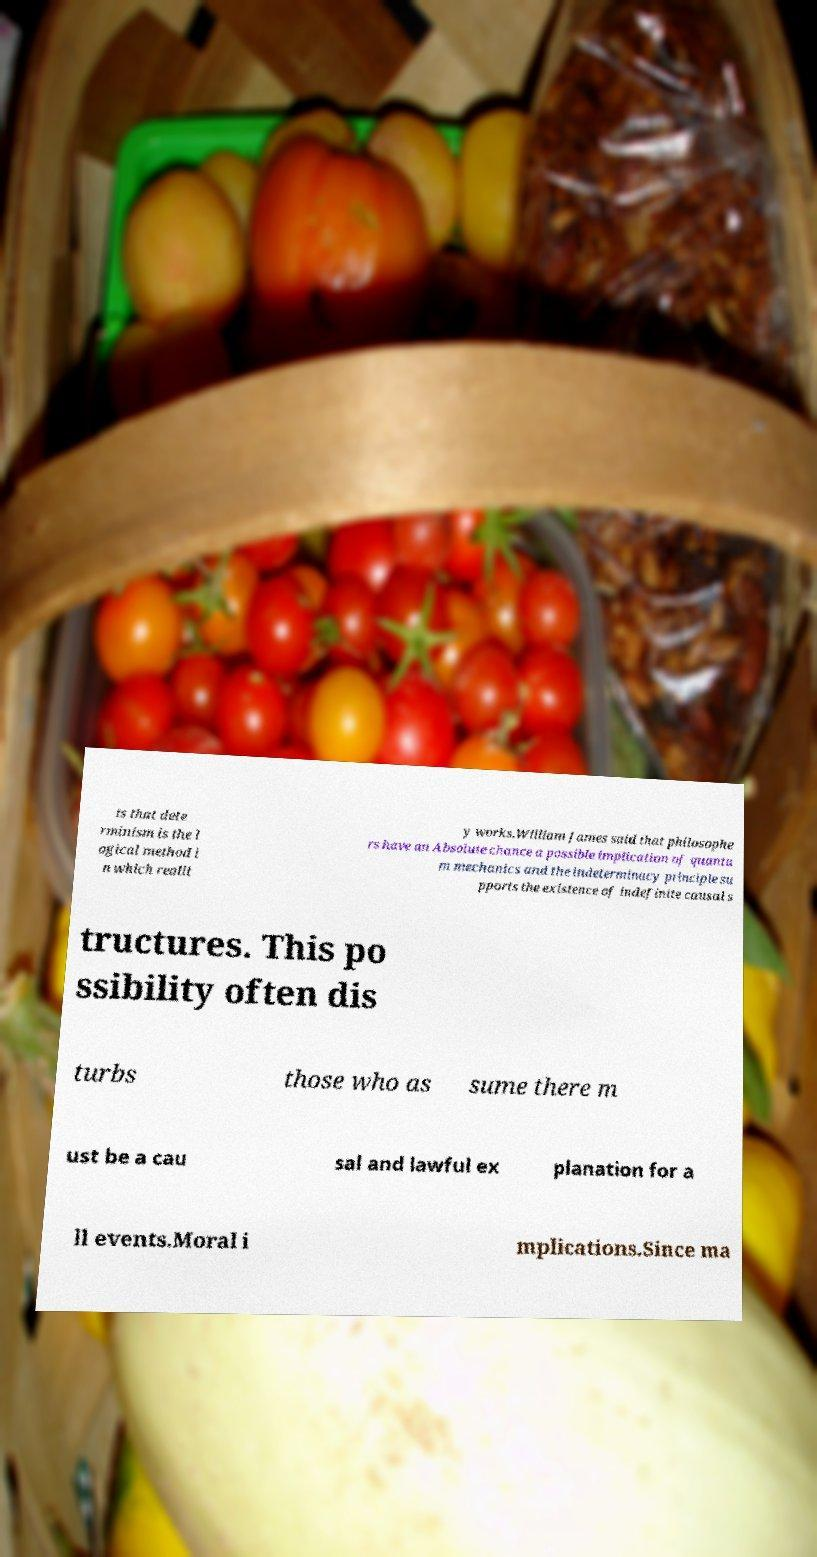Please read and relay the text visible in this image. What does it say? ts that dete rminism is the l ogical method i n which realit y works.William James said that philosophe rs have an Absolute chance a possible implication of quantu m mechanics and the indeterminacy principle su pports the existence of indefinite causal s tructures. This po ssibility often dis turbs those who as sume there m ust be a cau sal and lawful ex planation for a ll events.Moral i mplications.Since ma 